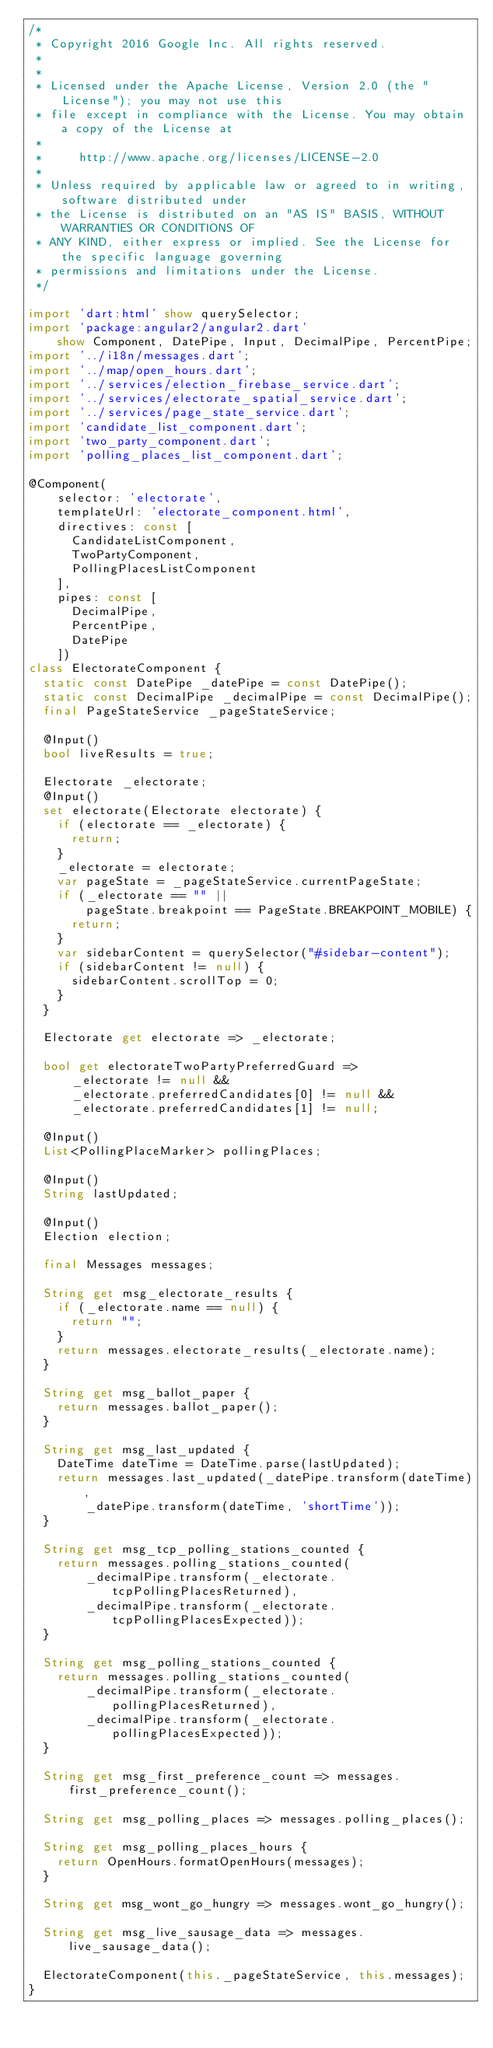Convert code to text. <code><loc_0><loc_0><loc_500><loc_500><_Dart_>/*
 * Copyright 2016 Google Inc. All rights reserved.
 *
 *
 * Licensed under the Apache License, Version 2.0 (the "License"); you may not use this
 * file except in compliance with the License. You may obtain a copy of the License at
 *
 *     http://www.apache.org/licenses/LICENSE-2.0
 *
 * Unless required by applicable law or agreed to in writing, software distributed under
 * the License is distributed on an "AS IS" BASIS, WITHOUT WARRANTIES OR CONDITIONS OF
 * ANY KIND, either express or implied. See the License for the specific language governing
 * permissions and limitations under the License.
 */

import 'dart:html' show querySelector;
import 'package:angular2/angular2.dart'
    show Component, DatePipe, Input, DecimalPipe, PercentPipe;
import '../i18n/messages.dart';
import '../map/open_hours.dart';
import '../services/election_firebase_service.dart';
import '../services/electorate_spatial_service.dart';
import '../services/page_state_service.dart';
import 'candidate_list_component.dart';
import 'two_party_component.dart';
import 'polling_places_list_component.dart';

@Component(
    selector: 'electorate',
    templateUrl: 'electorate_component.html',
    directives: const [
      CandidateListComponent,
      TwoPartyComponent,
      PollingPlacesListComponent
    ],
    pipes: const [
      DecimalPipe,
      PercentPipe,
      DatePipe
    ])
class ElectorateComponent {
  static const DatePipe _datePipe = const DatePipe();
  static const DecimalPipe _decimalPipe = const DecimalPipe();
  final PageStateService _pageStateService;

  @Input()
  bool liveResults = true;

  Electorate _electorate;
  @Input()
  set electorate(Electorate electorate) {
    if (electorate == _electorate) {
      return;
    }
    _electorate = electorate;
    var pageState = _pageStateService.currentPageState;
    if (_electorate == "" ||
        pageState.breakpoint == PageState.BREAKPOINT_MOBILE) {
      return;
    }
    var sidebarContent = querySelector("#sidebar-content");
    if (sidebarContent != null) {
      sidebarContent.scrollTop = 0;
    }
  }

  Electorate get electorate => _electorate;

  bool get electorateTwoPartyPreferredGuard =>
      _electorate != null &&
      _electorate.preferredCandidates[0] != null &&
      _electorate.preferredCandidates[1] != null;

  @Input()
  List<PollingPlaceMarker> pollingPlaces;

  @Input()
  String lastUpdated;

  @Input()
  Election election;

  final Messages messages;

  String get msg_electorate_results {
    if (_electorate.name == null) {
      return "";
    }
    return messages.electorate_results(_electorate.name);
  }

  String get msg_ballot_paper {
    return messages.ballot_paper();
  }

  String get msg_last_updated {
    DateTime dateTime = DateTime.parse(lastUpdated);
    return messages.last_updated(_datePipe.transform(dateTime),
        _datePipe.transform(dateTime, 'shortTime'));
  }

  String get msg_tcp_polling_stations_counted {
    return messages.polling_stations_counted(
        _decimalPipe.transform(_electorate.tcpPollingPlacesReturned),
        _decimalPipe.transform(_electorate.tcpPollingPlacesExpected));
  }

  String get msg_polling_stations_counted {
    return messages.polling_stations_counted(
        _decimalPipe.transform(_electorate.pollingPlacesReturned),
        _decimalPipe.transform(_electorate.pollingPlacesExpected));
  }

  String get msg_first_preference_count => messages.first_preference_count();

  String get msg_polling_places => messages.polling_places();

  String get msg_polling_places_hours {
    return OpenHours.formatOpenHours(messages);
  }

  String get msg_wont_go_hungry => messages.wont_go_hungry();

  String get msg_live_sausage_data => messages.live_sausage_data();

  ElectorateComponent(this._pageStateService, this.messages);
}
</code> 